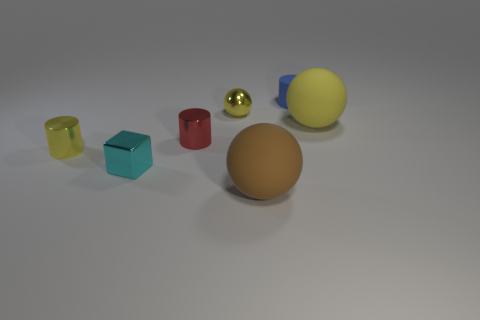Subtract 1 balls. How many balls are left? 2 Add 1 yellow shiny objects. How many objects exist? 8 Subtract all spheres. How many objects are left? 4 Subtract all red shiny cylinders. Subtract all yellow rubber things. How many objects are left? 5 Add 4 cylinders. How many cylinders are left? 7 Add 7 small cyan balls. How many small cyan balls exist? 7 Subtract 0 cyan balls. How many objects are left? 7 